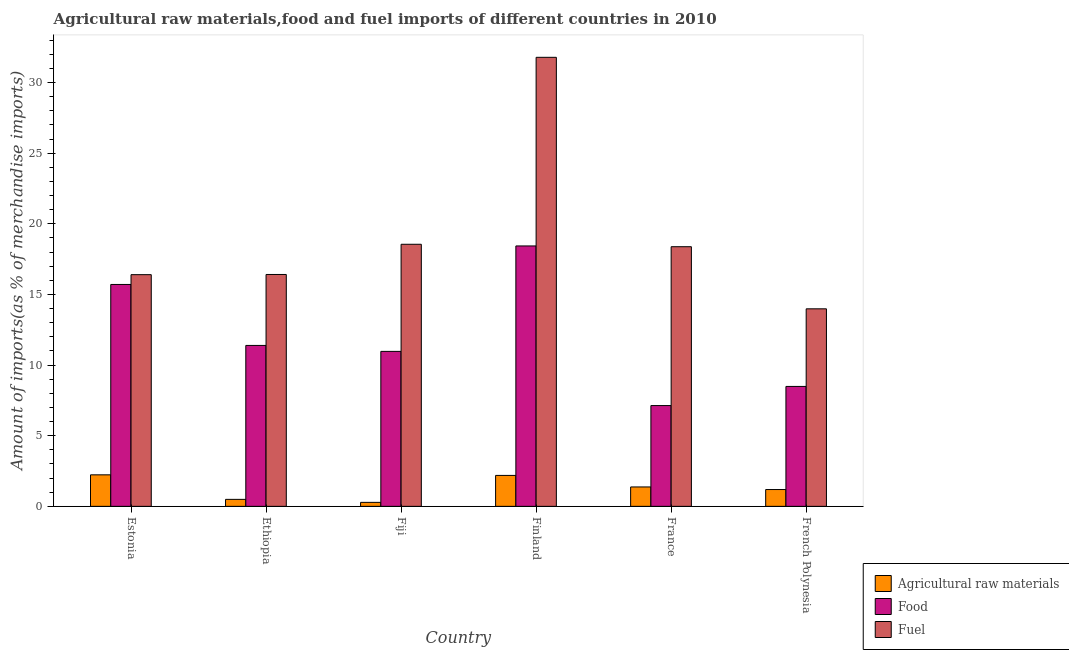How many bars are there on the 5th tick from the right?
Make the answer very short. 3. What is the label of the 6th group of bars from the left?
Your answer should be very brief. French Polynesia. In how many cases, is the number of bars for a given country not equal to the number of legend labels?
Your answer should be compact. 0. What is the percentage of food imports in French Polynesia?
Keep it short and to the point. 8.49. Across all countries, what is the maximum percentage of raw materials imports?
Provide a succinct answer. 2.23. Across all countries, what is the minimum percentage of raw materials imports?
Offer a very short reply. 0.28. In which country was the percentage of raw materials imports maximum?
Keep it short and to the point. Estonia. In which country was the percentage of fuel imports minimum?
Ensure brevity in your answer.  French Polynesia. What is the total percentage of fuel imports in the graph?
Provide a short and direct response. 115.52. What is the difference between the percentage of fuel imports in Estonia and that in France?
Your response must be concise. -1.98. What is the difference between the percentage of food imports in Estonia and the percentage of fuel imports in Ethiopia?
Give a very brief answer. -0.71. What is the average percentage of raw materials imports per country?
Offer a terse response. 1.29. What is the difference between the percentage of raw materials imports and percentage of food imports in Ethiopia?
Provide a short and direct response. -10.9. In how many countries, is the percentage of fuel imports greater than 13 %?
Your answer should be compact. 6. What is the ratio of the percentage of fuel imports in Estonia to that in Fiji?
Give a very brief answer. 0.88. Is the percentage of raw materials imports in Ethiopia less than that in France?
Your answer should be compact. Yes. What is the difference between the highest and the second highest percentage of raw materials imports?
Offer a very short reply. 0.04. What is the difference between the highest and the lowest percentage of fuel imports?
Your answer should be compact. 17.8. Is the sum of the percentage of raw materials imports in Ethiopia and French Polynesia greater than the maximum percentage of fuel imports across all countries?
Offer a terse response. No. What does the 1st bar from the left in Finland represents?
Make the answer very short. Agricultural raw materials. What does the 3rd bar from the right in Finland represents?
Your response must be concise. Agricultural raw materials. How many countries are there in the graph?
Make the answer very short. 6. Are the values on the major ticks of Y-axis written in scientific E-notation?
Offer a terse response. No. Does the graph contain grids?
Your answer should be compact. No. Where does the legend appear in the graph?
Keep it short and to the point. Bottom right. How many legend labels are there?
Your answer should be compact. 3. What is the title of the graph?
Make the answer very short. Agricultural raw materials,food and fuel imports of different countries in 2010. Does "Fuel" appear as one of the legend labels in the graph?
Your response must be concise. Yes. What is the label or title of the Y-axis?
Offer a terse response. Amount of imports(as % of merchandise imports). What is the Amount of imports(as % of merchandise imports) in Agricultural raw materials in Estonia?
Ensure brevity in your answer.  2.23. What is the Amount of imports(as % of merchandise imports) in Food in Estonia?
Make the answer very short. 15.71. What is the Amount of imports(as % of merchandise imports) of Fuel in Estonia?
Provide a succinct answer. 16.4. What is the Amount of imports(as % of merchandise imports) in Agricultural raw materials in Ethiopia?
Give a very brief answer. 0.49. What is the Amount of imports(as % of merchandise imports) in Food in Ethiopia?
Your response must be concise. 11.39. What is the Amount of imports(as % of merchandise imports) of Fuel in Ethiopia?
Make the answer very short. 16.41. What is the Amount of imports(as % of merchandise imports) in Agricultural raw materials in Fiji?
Provide a short and direct response. 0.28. What is the Amount of imports(as % of merchandise imports) in Food in Fiji?
Offer a terse response. 10.97. What is the Amount of imports(as % of merchandise imports) of Fuel in Fiji?
Offer a terse response. 18.55. What is the Amount of imports(as % of merchandise imports) of Agricultural raw materials in Finland?
Ensure brevity in your answer.  2.19. What is the Amount of imports(as % of merchandise imports) in Food in Finland?
Your answer should be very brief. 18.43. What is the Amount of imports(as % of merchandise imports) of Fuel in Finland?
Ensure brevity in your answer.  31.79. What is the Amount of imports(as % of merchandise imports) in Agricultural raw materials in France?
Your answer should be compact. 1.37. What is the Amount of imports(as % of merchandise imports) of Food in France?
Your answer should be very brief. 7.13. What is the Amount of imports(as % of merchandise imports) of Fuel in France?
Keep it short and to the point. 18.38. What is the Amount of imports(as % of merchandise imports) in Agricultural raw materials in French Polynesia?
Offer a very short reply. 1.19. What is the Amount of imports(as % of merchandise imports) of Food in French Polynesia?
Provide a short and direct response. 8.49. What is the Amount of imports(as % of merchandise imports) in Fuel in French Polynesia?
Give a very brief answer. 13.98. Across all countries, what is the maximum Amount of imports(as % of merchandise imports) of Agricultural raw materials?
Ensure brevity in your answer.  2.23. Across all countries, what is the maximum Amount of imports(as % of merchandise imports) of Food?
Ensure brevity in your answer.  18.43. Across all countries, what is the maximum Amount of imports(as % of merchandise imports) in Fuel?
Your answer should be compact. 31.79. Across all countries, what is the minimum Amount of imports(as % of merchandise imports) in Agricultural raw materials?
Keep it short and to the point. 0.28. Across all countries, what is the minimum Amount of imports(as % of merchandise imports) of Food?
Keep it short and to the point. 7.13. Across all countries, what is the minimum Amount of imports(as % of merchandise imports) in Fuel?
Keep it short and to the point. 13.98. What is the total Amount of imports(as % of merchandise imports) in Agricultural raw materials in the graph?
Make the answer very short. 7.76. What is the total Amount of imports(as % of merchandise imports) of Food in the graph?
Ensure brevity in your answer.  72.13. What is the total Amount of imports(as % of merchandise imports) in Fuel in the graph?
Provide a short and direct response. 115.52. What is the difference between the Amount of imports(as % of merchandise imports) in Agricultural raw materials in Estonia and that in Ethiopia?
Offer a very short reply. 1.74. What is the difference between the Amount of imports(as % of merchandise imports) in Food in Estonia and that in Ethiopia?
Offer a terse response. 4.32. What is the difference between the Amount of imports(as % of merchandise imports) of Fuel in Estonia and that in Ethiopia?
Offer a very short reply. -0.01. What is the difference between the Amount of imports(as % of merchandise imports) in Agricultural raw materials in Estonia and that in Fiji?
Offer a terse response. 1.95. What is the difference between the Amount of imports(as % of merchandise imports) of Food in Estonia and that in Fiji?
Ensure brevity in your answer.  4.74. What is the difference between the Amount of imports(as % of merchandise imports) in Fuel in Estonia and that in Fiji?
Make the answer very short. -2.15. What is the difference between the Amount of imports(as % of merchandise imports) of Agricultural raw materials in Estonia and that in Finland?
Provide a short and direct response. 0.04. What is the difference between the Amount of imports(as % of merchandise imports) of Food in Estonia and that in Finland?
Offer a very short reply. -2.73. What is the difference between the Amount of imports(as % of merchandise imports) in Fuel in Estonia and that in Finland?
Give a very brief answer. -15.39. What is the difference between the Amount of imports(as % of merchandise imports) in Agricultural raw materials in Estonia and that in France?
Offer a very short reply. 0.86. What is the difference between the Amount of imports(as % of merchandise imports) of Food in Estonia and that in France?
Your answer should be compact. 8.57. What is the difference between the Amount of imports(as % of merchandise imports) in Fuel in Estonia and that in France?
Your response must be concise. -1.98. What is the difference between the Amount of imports(as % of merchandise imports) in Agricultural raw materials in Estonia and that in French Polynesia?
Provide a succinct answer. 1.04. What is the difference between the Amount of imports(as % of merchandise imports) in Food in Estonia and that in French Polynesia?
Offer a very short reply. 7.22. What is the difference between the Amount of imports(as % of merchandise imports) of Fuel in Estonia and that in French Polynesia?
Provide a short and direct response. 2.42. What is the difference between the Amount of imports(as % of merchandise imports) in Agricultural raw materials in Ethiopia and that in Fiji?
Your answer should be compact. 0.21. What is the difference between the Amount of imports(as % of merchandise imports) of Food in Ethiopia and that in Fiji?
Offer a very short reply. 0.42. What is the difference between the Amount of imports(as % of merchandise imports) of Fuel in Ethiopia and that in Fiji?
Your answer should be very brief. -2.14. What is the difference between the Amount of imports(as % of merchandise imports) in Agricultural raw materials in Ethiopia and that in Finland?
Keep it short and to the point. -1.7. What is the difference between the Amount of imports(as % of merchandise imports) of Food in Ethiopia and that in Finland?
Provide a succinct answer. -7.04. What is the difference between the Amount of imports(as % of merchandise imports) of Fuel in Ethiopia and that in Finland?
Offer a very short reply. -15.37. What is the difference between the Amount of imports(as % of merchandise imports) of Agricultural raw materials in Ethiopia and that in France?
Make the answer very short. -0.88. What is the difference between the Amount of imports(as % of merchandise imports) in Food in Ethiopia and that in France?
Keep it short and to the point. 4.26. What is the difference between the Amount of imports(as % of merchandise imports) in Fuel in Ethiopia and that in France?
Keep it short and to the point. -1.97. What is the difference between the Amount of imports(as % of merchandise imports) of Agricultural raw materials in Ethiopia and that in French Polynesia?
Provide a succinct answer. -0.69. What is the difference between the Amount of imports(as % of merchandise imports) of Food in Ethiopia and that in French Polynesia?
Offer a very short reply. 2.9. What is the difference between the Amount of imports(as % of merchandise imports) of Fuel in Ethiopia and that in French Polynesia?
Give a very brief answer. 2.43. What is the difference between the Amount of imports(as % of merchandise imports) of Agricultural raw materials in Fiji and that in Finland?
Offer a very short reply. -1.91. What is the difference between the Amount of imports(as % of merchandise imports) of Food in Fiji and that in Finland?
Offer a very short reply. -7.46. What is the difference between the Amount of imports(as % of merchandise imports) in Fuel in Fiji and that in Finland?
Provide a succinct answer. -13.23. What is the difference between the Amount of imports(as % of merchandise imports) of Agricultural raw materials in Fiji and that in France?
Your answer should be very brief. -1.09. What is the difference between the Amount of imports(as % of merchandise imports) in Food in Fiji and that in France?
Offer a very short reply. 3.84. What is the difference between the Amount of imports(as % of merchandise imports) of Fuel in Fiji and that in France?
Provide a succinct answer. 0.17. What is the difference between the Amount of imports(as % of merchandise imports) of Agricultural raw materials in Fiji and that in French Polynesia?
Keep it short and to the point. -0.91. What is the difference between the Amount of imports(as % of merchandise imports) in Food in Fiji and that in French Polynesia?
Provide a succinct answer. 2.48. What is the difference between the Amount of imports(as % of merchandise imports) of Fuel in Fiji and that in French Polynesia?
Keep it short and to the point. 4.57. What is the difference between the Amount of imports(as % of merchandise imports) in Agricultural raw materials in Finland and that in France?
Provide a succinct answer. 0.82. What is the difference between the Amount of imports(as % of merchandise imports) of Food in Finland and that in France?
Offer a very short reply. 11.3. What is the difference between the Amount of imports(as % of merchandise imports) in Fuel in Finland and that in France?
Give a very brief answer. 13.41. What is the difference between the Amount of imports(as % of merchandise imports) in Agricultural raw materials in Finland and that in French Polynesia?
Offer a very short reply. 1. What is the difference between the Amount of imports(as % of merchandise imports) in Food in Finland and that in French Polynesia?
Your answer should be very brief. 9.95. What is the difference between the Amount of imports(as % of merchandise imports) in Fuel in Finland and that in French Polynesia?
Offer a terse response. 17.8. What is the difference between the Amount of imports(as % of merchandise imports) in Agricultural raw materials in France and that in French Polynesia?
Give a very brief answer. 0.18. What is the difference between the Amount of imports(as % of merchandise imports) of Food in France and that in French Polynesia?
Your response must be concise. -1.35. What is the difference between the Amount of imports(as % of merchandise imports) in Fuel in France and that in French Polynesia?
Provide a succinct answer. 4.4. What is the difference between the Amount of imports(as % of merchandise imports) of Agricultural raw materials in Estonia and the Amount of imports(as % of merchandise imports) of Food in Ethiopia?
Offer a very short reply. -9.16. What is the difference between the Amount of imports(as % of merchandise imports) in Agricultural raw materials in Estonia and the Amount of imports(as % of merchandise imports) in Fuel in Ethiopia?
Provide a short and direct response. -14.18. What is the difference between the Amount of imports(as % of merchandise imports) of Food in Estonia and the Amount of imports(as % of merchandise imports) of Fuel in Ethiopia?
Offer a terse response. -0.71. What is the difference between the Amount of imports(as % of merchandise imports) in Agricultural raw materials in Estonia and the Amount of imports(as % of merchandise imports) in Food in Fiji?
Your answer should be compact. -8.74. What is the difference between the Amount of imports(as % of merchandise imports) in Agricultural raw materials in Estonia and the Amount of imports(as % of merchandise imports) in Fuel in Fiji?
Provide a succinct answer. -16.32. What is the difference between the Amount of imports(as % of merchandise imports) in Food in Estonia and the Amount of imports(as % of merchandise imports) in Fuel in Fiji?
Offer a terse response. -2.85. What is the difference between the Amount of imports(as % of merchandise imports) of Agricultural raw materials in Estonia and the Amount of imports(as % of merchandise imports) of Food in Finland?
Keep it short and to the point. -16.2. What is the difference between the Amount of imports(as % of merchandise imports) in Agricultural raw materials in Estonia and the Amount of imports(as % of merchandise imports) in Fuel in Finland?
Your response must be concise. -29.56. What is the difference between the Amount of imports(as % of merchandise imports) of Food in Estonia and the Amount of imports(as % of merchandise imports) of Fuel in Finland?
Make the answer very short. -16.08. What is the difference between the Amount of imports(as % of merchandise imports) in Agricultural raw materials in Estonia and the Amount of imports(as % of merchandise imports) in Food in France?
Provide a succinct answer. -4.9. What is the difference between the Amount of imports(as % of merchandise imports) of Agricultural raw materials in Estonia and the Amount of imports(as % of merchandise imports) of Fuel in France?
Offer a terse response. -16.15. What is the difference between the Amount of imports(as % of merchandise imports) in Food in Estonia and the Amount of imports(as % of merchandise imports) in Fuel in France?
Provide a short and direct response. -2.67. What is the difference between the Amount of imports(as % of merchandise imports) of Agricultural raw materials in Estonia and the Amount of imports(as % of merchandise imports) of Food in French Polynesia?
Keep it short and to the point. -6.26. What is the difference between the Amount of imports(as % of merchandise imports) of Agricultural raw materials in Estonia and the Amount of imports(as % of merchandise imports) of Fuel in French Polynesia?
Make the answer very short. -11.75. What is the difference between the Amount of imports(as % of merchandise imports) of Food in Estonia and the Amount of imports(as % of merchandise imports) of Fuel in French Polynesia?
Provide a short and direct response. 1.72. What is the difference between the Amount of imports(as % of merchandise imports) of Agricultural raw materials in Ethiopia and the Amount of imports(as % of merchandise imports) of Food in Fiji?
Provide a short and direct response. -10.48. What is the difference between the Amount of imports(as % of merchandise imports) of Agricultural raw materials in Ethiopia and the Amount of imports(as % of merchandise imports) of Fuel in Fiji?
Provide a short and direct response. -18.06. What is the difference between the Amount of imports(as % of merchandise imports) in Food in Ethiopia and the Amount of imports(as % of merchandise imports) in Fuel in Fiji?
Your response must be concise. -7.16. What is the difference between the Amount of imports(as % of merchandise imports) of Agricultural raw materials in Ethiopia and the Amount of imports(as % of merchandise imports) of Food in Finland?
Your answer should be very brief. -17.94. What is the difference between the Amount of imports(as % of merchandise imports) in Agricultural raw materials in Ethiopia and the Amount of imports(as % of merchandise imports) in Fuel in Finland?
Provide a short and direct response. -31.29. What is the difference between the Amount of imports(as % of merchandise imports) of Food in Ethiopia and the Amount of imports(as % of merchandise imports) of Fuel in Finland?
Give a very brief answer. -20.4. What is the difference between the Amount of imports(as % of merchandise imports) in Agricultural raw materials in Ethiopia and the Amount of imports(as % of merchandise imports) in Food in France?
Your answer should be very brief. -6.64. What is the difference between the Amount of imports(as % of merchandise imports) in Agricultural raw materials in Ethiopia and the Amount of imports(as % of merchandise imports) in Fuel in France?
Provide a short and direct response. -17.89. What is the difference between the Amount of imports(as % of merchandise imports) in Food in Ethiopia and the Amount of imports(as % of merchandise imports) in Fuel in France?
Your response must be concise. -6.99. What is the difference between the Amount of imports(as % of merchandise imports) in Agricultural raw materials in Ethiopia and the Amount of imports(as % of merchandise imports) in Food in French Polynesia?
Your answer should be very brief. -7.99. What is the difference between the Amount of imports(as % of merchandise imports) of Agricultural raw materials in Ethiopia and the Amount of imports(as % of merchandise imports) of Fuel in French Polynesia?
Your answer should be very brief. -13.49. What is the difference between the Amount of imports(as % of merchandise imports) of Food in Ethiopia and the Amount of imports(as % of merchandise imports) of Fuel in French Polynesia?
Keep it short and to the point. -2.59. What is the difference between the Amount of imports(as % of merchandise imports) in Agricultural raw materials in Fiji and the Amount of imports(as % of merchandise imports) in Food in Finland?
Your answer should be very brief. -18.15. What is the difference between the Amount of imports(as % of merchandise imports) in Agricultural raw materials in Fiji and the Amount of imports(as % of merchandise imports) in Fuel in Finland?
Your response must be concise. -31.51. What is the difference between the Amount of imports(as % of merchandise imports) in Food in Fiji and the Amount of imports(as % of merchandise imports) in Fuel in Finland?
Provide a short and direct response. -20.82. What is the difference between the Amount of imports(as % of merchandise imports) of Agricultural raw materials in Fiji and the Amount of imports(as % of merchandise imports) of Food in France?
Keep it short and to the point. -6.85. What is the difference between the Amount of imports(as % of merchandise imports) in Agricultural raw materials in Fiji and the Amount of imports(as % of merchandise imports) in Fuel in France?
Provide a succinct answer. -18.1. What is the difference between the Amount of imports(as % of merchandise imports) of Food in Fiji and the Amount of imports(as % of merchandise imports) of Fuel in France?
Provide a short and direct response. -7.41. What is the difference between the Amount of imports(as % of merchandise imports) in Agricultural raw materials in Fiji and the Amount of imports(as % of merchandise imports) in Food in French Polynesia?
Your answer should be very brief. -8.21. What is the difference between the Amount of imports(as % of merchandise imports) in Agricultural raw materials in Fiji and the Amount of imports(as % of merchandise imports) in Fuel in French Polynesia?
Provide a short and direct response. -13.7. What is the difference between the Amount of imports(as % of merchandise imports) of Food in Fiji and the Amount of imports(as % of merchandise imports) of Fuel in French Polynesia?
Ensure brevity in your answer.  -3.01. What is the difference between the Amount of imports(as % of merchandise imports) of Agricultural raw materials in Finland and the Amount of imports(as % of merchandise imports) of Food in France?
Provide a succinct answer. -4.94. What is the difference between the Amount of imports(as % of merchandise imports) of Agricultural raw materials in Finland and the Amount of imports(as % of merchandise imports) of Fuel in France?
Offer a very short reply. -16.19. What is the difference between the Amount of imports(as % of merchandise imports) in Food in Finland and the Amount of imports(as % of merchandise imports) in Fuel in France?
Offer a terse response. 0.05. What is the difference between the Amount of imports(as % of merchandise imports) of Agricultural raw materials in Finland and the Amount of imports(as % of merchandise imports) of Food in French Polynesia?
Ensure brevity in your answer.  -6.3. What is the difference between the Amount of imports(as % of merchandise imports) of Agricultural raw materials in Finland and the Amount of imports(as % of merchandise imports) of Fuel in French Polynesia?
Your answer should be very brief. -11.79. What is the difference between the Amount of imports(as % of merchandise imports) in Food in Finland and the Amount of imports(as % of merchandise imports) in Fuel in French Polynesia?
Your answer should be compact. 4.45. What is the difference between the Amount of imports(as % of merchandise imports) of Agricultural raw materials in France and the Amount of imports(as % of merchandise imports) of Food in French Polynesia?
Offer a very short reply. -7.12. What is the difference between the Amount of imports(as % of merchandise imports) in Agricultural raw materials in France and the Amount of imports(as % of merchandise imports) in Fuel in French Polynesia?
Make the answer very short. -12.61. What is the difference between the Amount of imports(as % of merchandise imports) of Food in France and the Amount of imports(as % of merchandise imports) of Fuel in French Polynesia?
Offer a very short reply. -6.85. What is the average Amount of imports(as % of merchandise imports) of Agricultural raw materials per country?
Your answer should be compact. 1.29. What is the average Amount of imports(as % of merchandise imports) of Food per country?
Give a very brief answer. 12.02. What is the average Amount of imports(as % of merchandise imports) of Fuel per country?
Ensure brevity in your answer.  19.25. What is the difference between the Amount of imports(as % of merchandise imports) in Agricultural raw materials and Amount of imports(as % of merchandise imports) in Food in Estonia?
Ensure brevity in your answer.  -13.48. What is the difference between the Amount of imports(as % of merchandise imports) of Agricultural raw materials and Amount of imports(as % of merchandise imports) of Fuel in Estonia?
Ensure brevity in your answer.  -14.17. What is the difference between the Amount of imports(as % of merchandise imports) of Food and Amount of imports(as % of merchandise imports) of Fuel in Estonia?
Provide a short and direct response. -0.69. What is the difference between the Amount of imports(as % of merchandise imports) in Agricultural raw materials and Amount of imports(as % of merchandise imports) in Food in Ethiopia?
Make the answer very short. -10.9. What is the difference between the Amount of imports(as % of merchandise imports) of Agricultural raw materials and Amount of imports(as % of merchandise imports) of Fuel in Ethiopia?
Your answer should be compact. -15.92. What is the difference between the Amount of imports(as % of merchandise imports) of Food and Amount of imports(as % of merchandise imports) of Fuel in Ethiopia?
Give a very brief answer. -5.02. What is the difference between the Amount of imports(as % of merchandise imports) of Agricultural raw materials and Amount of imports(as % of merchandise imports) of Food in Fiji?
Your answer should be very brief. -10.69. What is the difference between the Amount of imports(as % of merchandise imports) in Agricultural raw materials and Amount of imports(as % of merchandise imports) in Fuel in Fiji?
Make the answer very short. -18.27. What is the difference between the Amount of imports(as % of merchandise imports) in Food and Amount of imports(as % of merchandise imports) in Fuel in Fiji?
Give a very brief answer. -7.58. What is the difference between the Amount of imports(as % of merchandise imports) of Agricultural raw materials and Amount of imports(as % of merchandise imports) of Food in Finland?
Offer a terse response. -16.24. What is the difference between the Amount of imports(as % of merchandise imports) of Agricultural raw materials and Amount of imports(as % of merchandise imports) of Fuel in Finland?
Provide a short and direct response. -29.6. What is the difference between the Amount of imports(as % of merchandise imports) in Food and Amount of imports(as % of merchandise imports) in Fuel in Finland?
Keep it short and to the point. -13.35. What is the difference between the Amount of imports(as % of merchandise imports) of Agricultural raw materials and Amount of imports(as % of merchandise imports) of Food in France?
Your answer should be compact. -5.76. What is the difference between the Amount of imports(as % of merchandise imports) in Agricultural raw materials and Amount of imports(as % of merchandise imports) in Fuel in France?
Provide a short and direct response. -17.01. What is the difference between the Amount of imports(as % of merchandise imports) in Food and Amount of imports(as % of merchandise imports) in Fuel in France?
Provide a succinct answer. -11.25. What is the difference between the Amount of imports(as % of merchandise imports) in Agricultural raw materials and Amount of imports(as % of merchandise imports) in Food in French Polynesia?
Ensure brevity in your answer.  -7.3. What is the difference between the Amount of imports(as % of merchandise imports) of Agricultural raw materials and Amount of imports(as % of merchandise imports) of Fuel in French Polynesia?
Make the answer very short. -12.79. What is the difference between the Amount of imports(as % of merchandise imports) of Food and Amount of imports(as % of merchandise imports) of Fuel in French Polynesia?
Your answer should be very brief. -5.49. What is the ratio of the Amount of imports(as % of merchandise imports) in Agricultural raw materials in Estonia to that in Ethiopia?
Keep it short and to the point. 4.51. What is the ratio of the Amount of imports(as % of merchandise imports) of Food in Estonia to that in Ethiopia?
Your answer should be compact. 1.38. What is the ratio of the Amount of imports(as % of merchandise imports) in Agricultural raw materials in Estonia to that in Fiji?
Keep it short and to the point. 7.93. What is the ratio of the Amount of imports(as % of merchandise imports) in Food in Estonia to that in Fiji?
Provide a short and direct response. 1.43. What is the ratio of the Amount of imports(as % of merchandise imports) in Fuel in Estonia to that in Fiji?
Offer a very short reply. 0.88. What is the ratio of the Amount of imports(as % of merchandise imports) of Agricultural raw materials in Estonia to that in Finland?
Offer a terse response. 1.02. What is the ratio of the Amount of imports(as % of merchandise imports) in Food in Estonia to that in Finland?
Offer a very short reply. 0.85. What is the ratio of the Amount of imports(as % of merchandise imports) in Fuel in Estonia to that in Finland?
Keep it short and to the point. 0.52. What is the ratio of the Amount of imports(as % of merchandise imports) in Agricultural raw materials in Estonia to that in France?
Your answer should be very brief. 1.62. What is the ratio of the Amount of imports(as % of merchandise imports) in Food in Estonia to that in France?
Offer a terse response. 2.2. What is the ratio of the Amount of imports(as % of merchandise imports) of Fuel in Estonia to that in France?
Ensure brevity in your answer.  0.89. What is the ratio of the Amount of imports(as % of merchandise imports) in Agricultural raw materials in Estonia to that in French Polynesia?
Keep it short and to the point. 1.88. What is the ratio of the Amount of imports(as % of merchandise imports) in Food in Estonia to that in French Polynesia?
Your answer should be compact. 1.85. What is the ratio of the Amount of imports(as % of merchandise imports) of Fuel in Estonia to that in French Polynesia?
Provide a succinct answer. 1.17. What is the ratio of the Amount of imports(as % of merchandise imports) in Agricultural raw materials in Ethiopia to that in Fiji?
Give a very brief answer. 1.76. What is the ratio of the Amount of imports(as % of merchandise imports) of Food in Ethiopia to that in Fiji?
Your response must be concise. 1.04. What is the ratio of the Amount of imports(as % of merchandise imports) in Fuel in Ethiopia to that in Fiji?
Offer a very short reply. 0.88. What is the ratio of the Amount of imports(as % of merchandise imports) in Agricultural raw materials in Ethiopia to that in Finland?
Your response must be concise. 0.23. What is the ratio of the Amount of imports(as % of merchandise imports) in Food in Ethiopia to that in Finland?
Your response must be concise. 0.62. What is the ratio of the Amount of imports(as % of merchandise imports) in Fuel in Ethiopia to that in Finland?
Your response must be concise. 0.52. What is the ratio of the Amount of imports(as % of merchandise imports) of Agricultural raw materials in Ethiopia to that in France?
Keep it short and to the point. 0.36. What is the ratio of the Amount of imports(as % of merchandise imports) of Food in Ethiopia to that in France?
Ensure brevity in your answer.  1.6. What is the ratio of the Amount of imports(as % of merchandise imports) in Fuel in Ethiopia to that in France?
Your answer should be compact. 0.89. What is the ratio of the Amount of imports(as % of merchandise imports) in Agricultural raw materials in Ethiopia to that in French Polynesia?
Your answer should be compact. 0.42. What is the ratio of the Amount of imports(as % of merchandise imports) of Food in Ethiopia to that in French Polynesia?
Your answer should be very brief. 1.34. What is the ratio of the Amount of imports(as % of merchandise imports) in Fuel in Ethiopia to that in French Polynesia?
Your answer should be compact. 1.17. What is the ratio of the Amount of imports(as % of merchandise imports) of Agricultural raw materials in Fiji to that in Finland?
Make the answer very short. 0.13. What is the ratio of the Amount of imports(as % of merchandise imports) in Food in Fiji to that in Finland?
Your answer should be compact. 0.6. What is the ratio of the Amount of imports(as % of merchandise imports) in Fuel in Fiji to that in Finland?
Provide a succinct answer. 0.58. What is the ratio of the Amount of imports(as % of merchandise imports) of Agricultural raw materials in Fiji to that in France?
Keep it short and to the point. 0.2. What is the ratio of the Amount of imports(as % of merchandise imports) of Food in Fiji to that in France?
Your response must be concise. 1.54. What is the ratio of the Amount of imports(as % of merchandise imports) in Fuel in Fiji to that in France?
Offer a very short reply. 1.01. What is the ratio of the Amount of imports(as % of merchandise imports) of Agricultural raw materials in Fiji to that in French Polynesia?
Give a very brief answer. 0.24. What is the ratio of the Amount of imports(as % of merchandise imports) of Food in Fiji to that in French Polynesia?
Your response must be concise. 1.29. What is the ratio of the Amount of imports(as % of merchandise imports) in Fuel in Fiji to that in French Polynesia?
Provide a short and direct response. 1.33. What is the ratio of the Amount of imports(as % of merchandise imports) in Agricultural raw materials in Finland to that in France?
Your answer should be compact. 1.59. What is the ratio of the Amount of imports(as % of merchandise imports) in Food in Finland to that in France?
Offer a terse response. 2.58. What is the ratio of the Amount of imports(as % of merchandise imports) in Fuel in Finland to that in France?
Make the answer very short. 1.73. What is the ratio of the Amount of imports(as % of merchandise imports) of Agricultural raw materials in Finland to that in French Polynesia?
Make the answer very short. 1.84. What is the ratio of the Amount of imports(as % of merchandise imports) of Food in Finland to that in French Polynesia?
Ensure brevity in your answer.  2.17. What is the ratio of the Amount of imports(as % of merchandise imports) in Fuel in Finland to that in French Polynesia?
Offer a terse response. 2.27. What is the ratio of the Amount of imports(as % of merchandise imports) in Agricultural raw materials in France to that in French Polynesia?
Your answer should be compact. 1.15. What is the ratio of the Amount of imports(as % of merchandise imports) in Food in France to that in French Polynesia?
Ensure brevity in your answer.  0.84. What is the ratio of the Amount of imports(as % of merchandise imports) in Fuel in France to that in French Polynesia?
Make the answer very short. 1.31. What is the difference between the highest and the second highest Amount of imports(as % of merchandise imports) of Agricultural raw materials?
Your answer should be very brief. 0.04. What is the difference between the highest and the second highest Amount of imports(as % of merchandise imports) in Food?
Keep it short and to the point. 2.73. What is the difference between the highest and the second highest Amount of imports(as % of merchandise imports) of Fuel?
Ensure brevity in your answer.  13.23. What is the difference between the highest and the lowest Amount of imports(as % of merchandise imports) in Agricultural raw materials?
Ensure brevity in your answer.  1.95. What is the difference between the highest and the lowest Amount of imports(as % of merchandise imports) in Food?
Ensure brevity in your answer.  11.3. What is the difference between the highest and the lowest Amount of imports(as % of merchandise imports) in Fuel?
Your answer should be very brief. 17.8. 